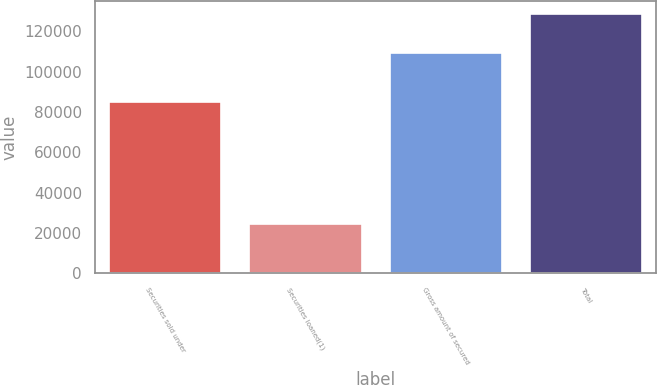<chart> <loc_0><loc_0><loc_500><loc_500><bar_chart><fcel>Securities sold under<fcel>Securities loaned(1)<fcel>Gross amount of secured<fcel>Total<nl><fcel>84749<fcel>24387<fcel>109136<fcel>128452<nl></chart> 